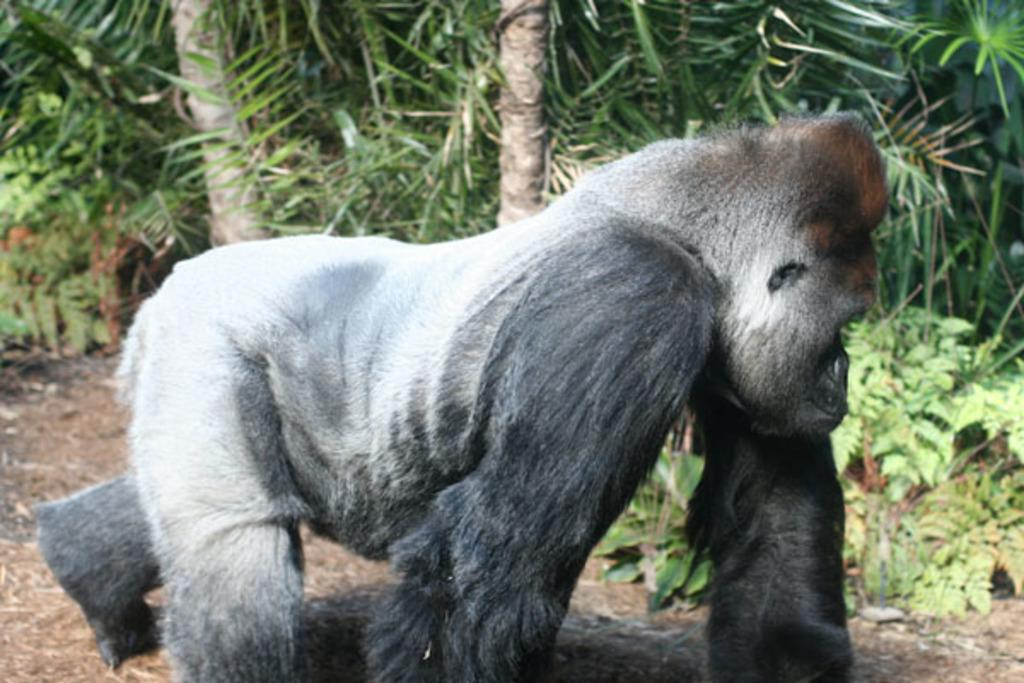What type of animal is in the image? There is a gorilla in the image. What is the gorilla doing in the image? The gorilla is walking on the land in the image. What type of vegetation can be seen in the image? There are trees and plants in the image. What type of verse can be heard being recited by the gorilla in the image? There is no indication in the image that the gorilla is reciting any verse, so it cannot be determined from the picture. 